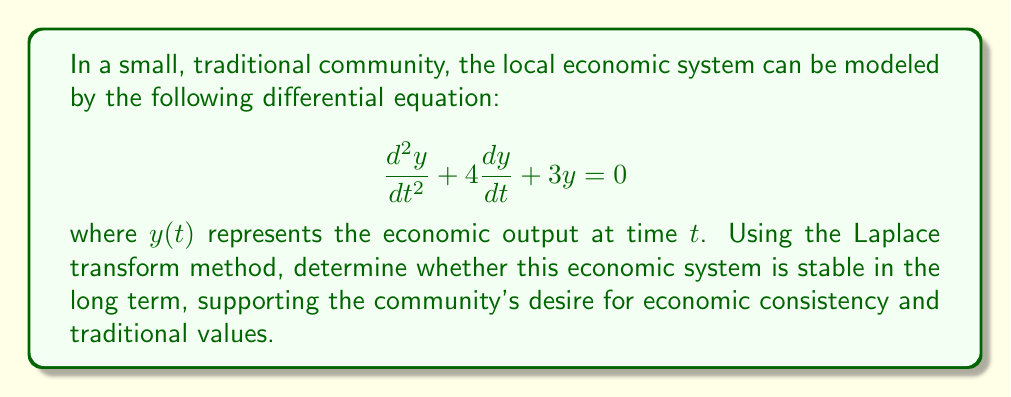Provide a solution to this math problem. To analyze the stability of this economic system using Laplace transforms, we'll follow these steps:

1) Take the Laplace transform of both sides of the equation:
   $$\mathcal{L}\left\{\frac{d^2y}{dt^2} + 4\frac{dy}{dt} + 3y\right\} = \mathcal{L}\{0\}$$

2) Using Laplace transform properties:
   $$s^2Y(s) - sy(0) - y'(0) + 4[sY(s) - y(0)] + 3Y(s) = 0$$

3) Assume initial conditions $y(0) = 0$ and $y'(0) = 0$ for simplicity:
   $$s^2Y(s) + 4sY(s) + 3Y(s) = 0$$

4) Factor out $Y(s)$:
   $$Y(s)(s^2 + 4s + 3) = 0$$

5) The characteristic equation is:
   $$s^2 + 4s + 3 = 0$$

6) Solve the characteristic equation:
   $$(s + 1)(s + 3) = 0$$
   $s = -1$ or $s = -3$

7) The stability of the system depends on the roots of the characteristic equation. For a system to be stable, all roots must have negative real parts. In this case, both roots (-1 and -3) are negative real numbers.

8) The general solution in the time domain will be of the form:
   $$y(t) = c_1e^{-t} + c_2e^{-3t}$$
   where $c_1$ and $c_2$ are constants determined by initial conditions.

9) As $t \to \infty$, both $e^{-t}$ and $e^{-3t}$ approach zero, meaning the system output will converge to zero over time.
Answer: The economic system is stable in the long term. Both roots of the characteristic equation are negative real numbers (-1 and -3), indicating that any perturbations in the economic output will decay over time, returning the system to equilibrium. This stability supports the community's desire for economic consistency and traditional values. 